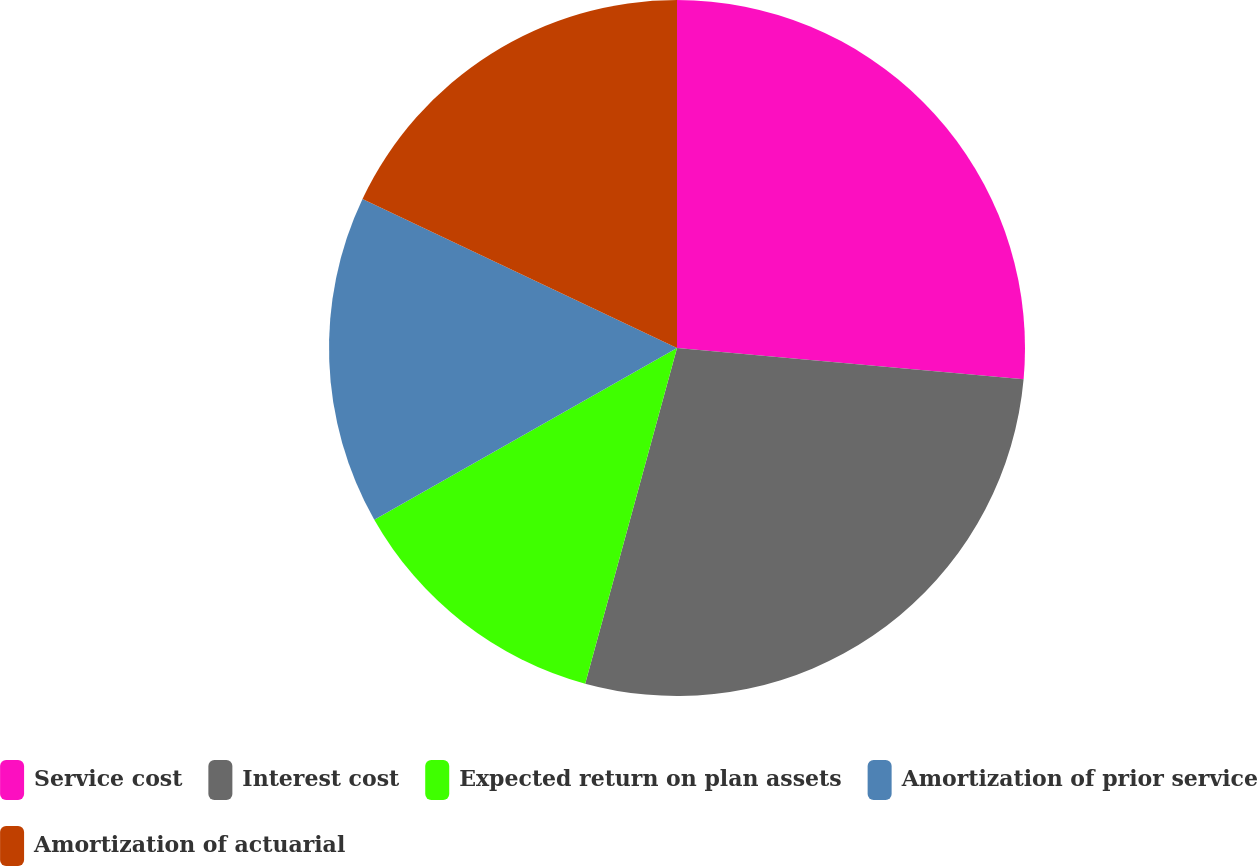Convert chart. <chart><loc_0><loc_0><loc_500><loc_500><pie_chart><fcel>Service cost<fcel>Interest cost<fcel>Expected return on plan assets<fcel>Amortization of prior service<fcel>Amortization of actuarial<nl><fcel>26.43%<fcel>27.82%<fcel>12.54%<fcel>15.25%<fcel>17.96%<nl></chart> 